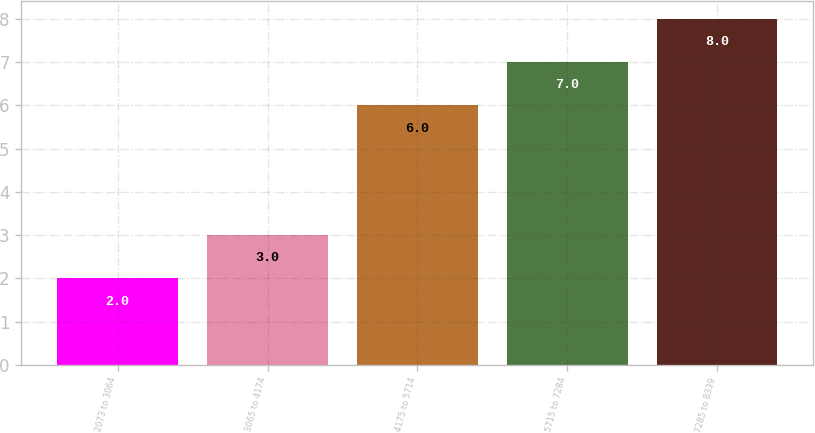Convert chart to OTSL. <chart><loc_0><loc_0><loc_500><loc_500><bar_chart><fcel>2073 to 3064<fcel>3065 to 4174<fcel>4175 to 5714<fcel>5715 to 7284<fcel>7285 to 8339<nl><fcel>2<fcel>3<fcel>6<fcel>7<fcel>8<nl></chart> 